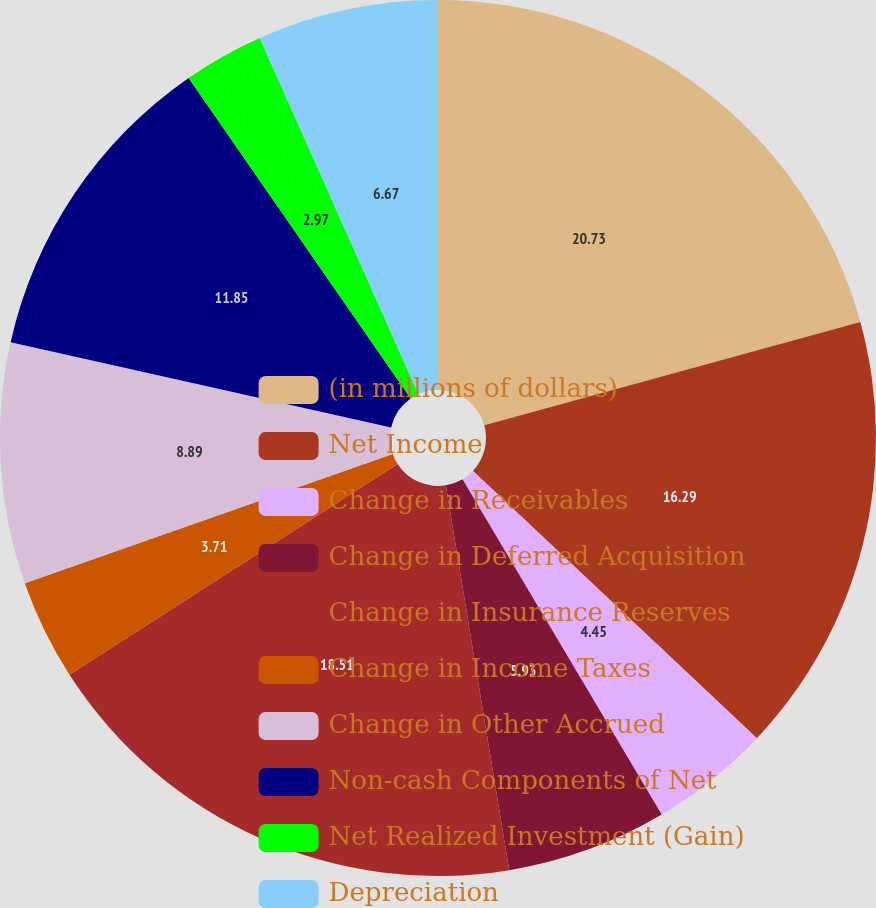Convert chart. <chart><loc_0><loc_0><loc_500><loc_500><pie_chart><fcel>(in millions of dollars)<fcel>Net Income<fcel>Change in Receivables<fcel>Change in Deferred Acquisition<fcel>Change in Insurance Reserves<fcel>Change in Income Taxes<fcel>Change in Other Accrued<fcel>Non-cash Components of Net<fcel>Net Realized Investment (Gain)<fcel>Depreciation<nl><fcel>20.73%<fcel>16.29%<fcel>4.45%<fcel>5.93%<fcel>18.51%<fcel>3.71%<fcel>8.89%<fcel>11.85%<fcel>2.97%<fcel>6.67%<nl></chart> 